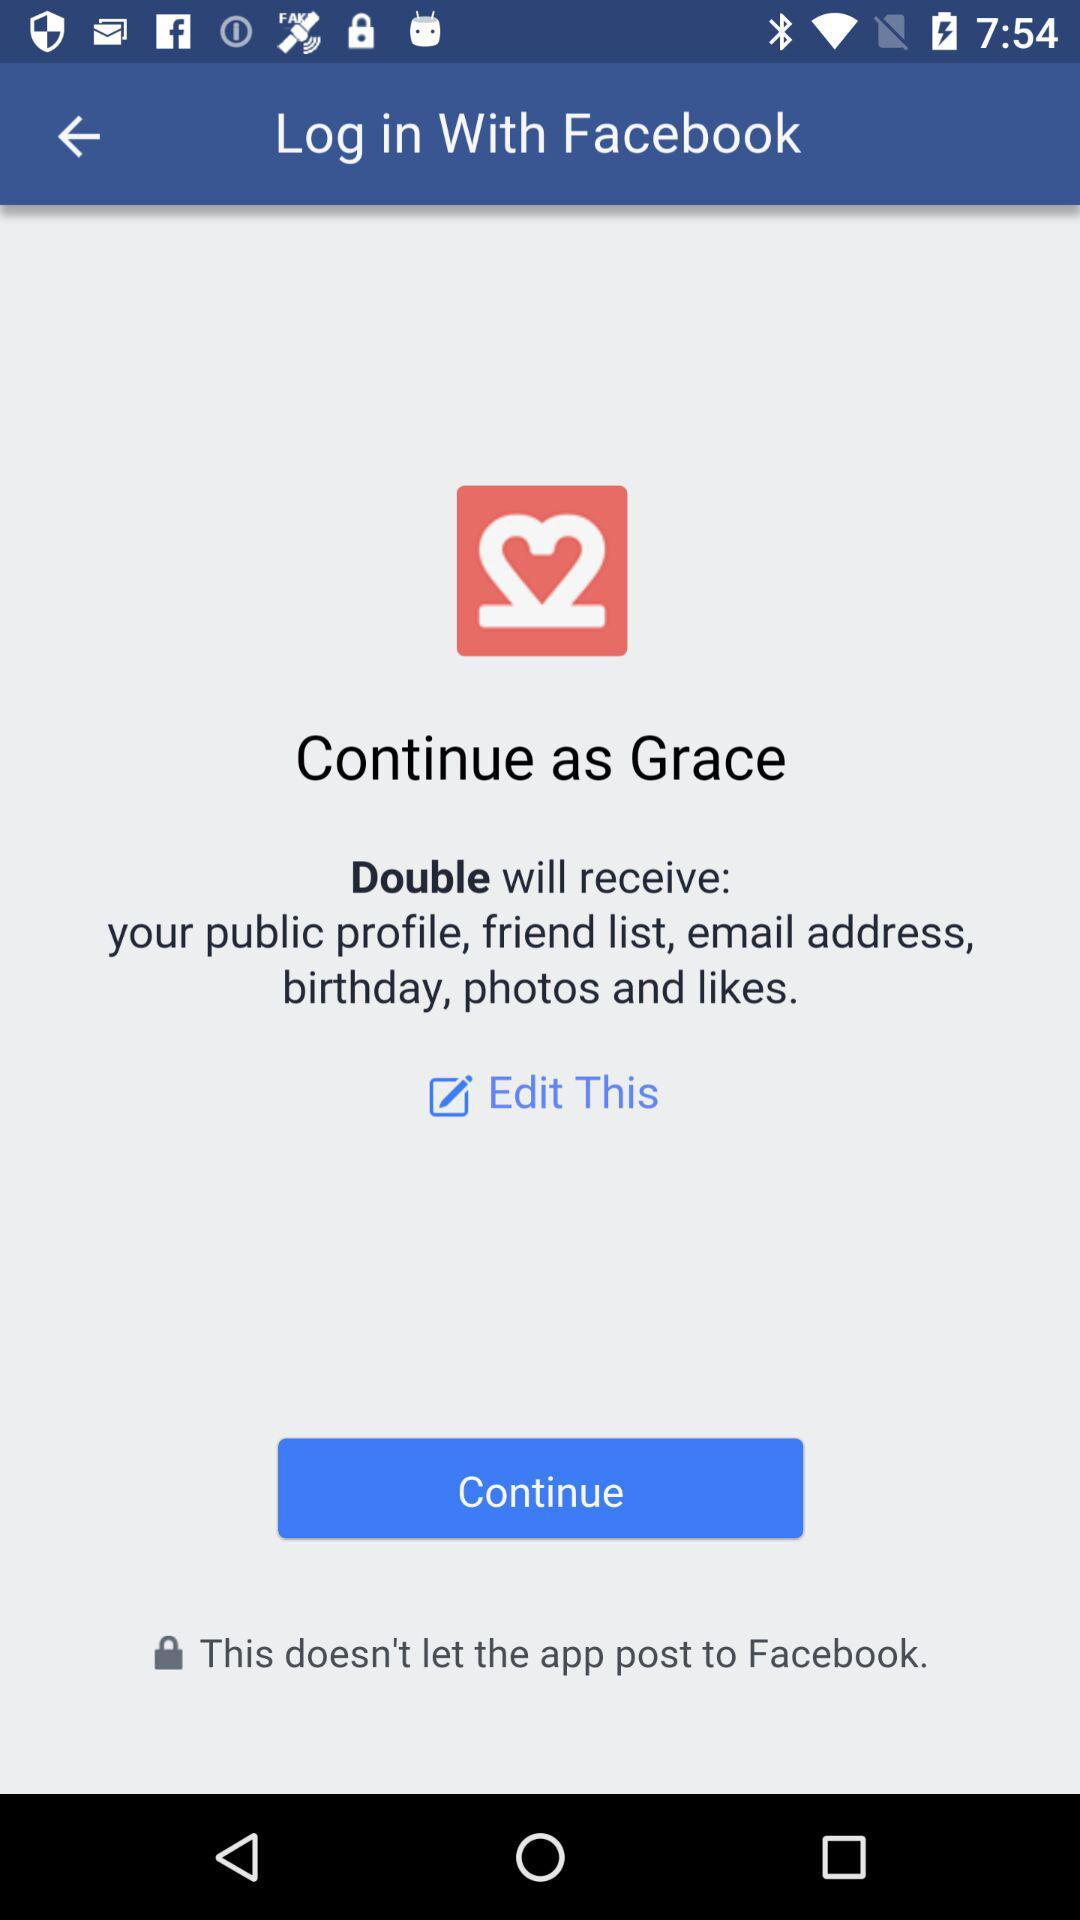What application is asking for permission? The application asking for access is Double. 